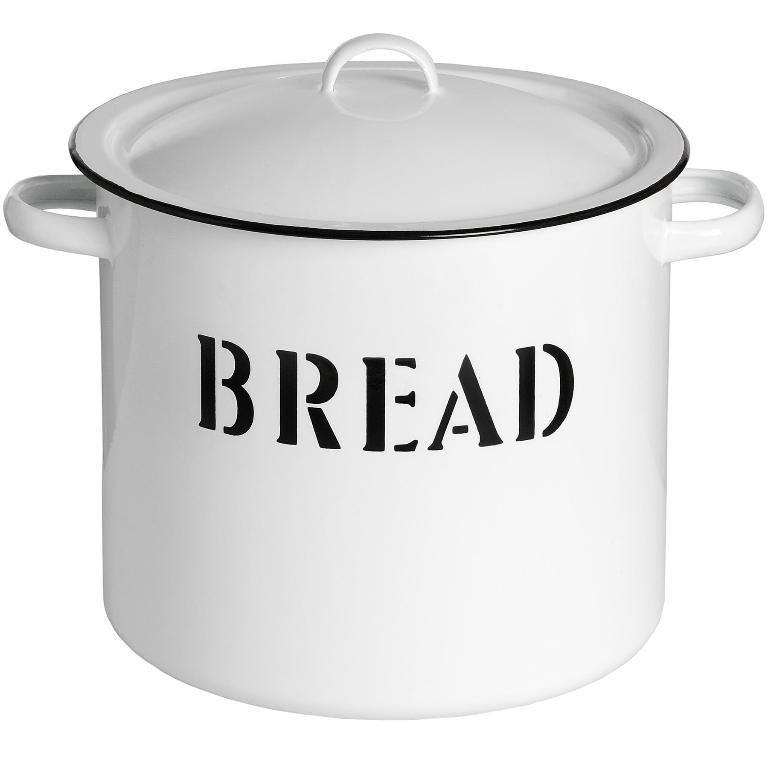<image>
Relay a brief, clear account of the picture shown. Black and white jar with bread in decorative text on the front. 